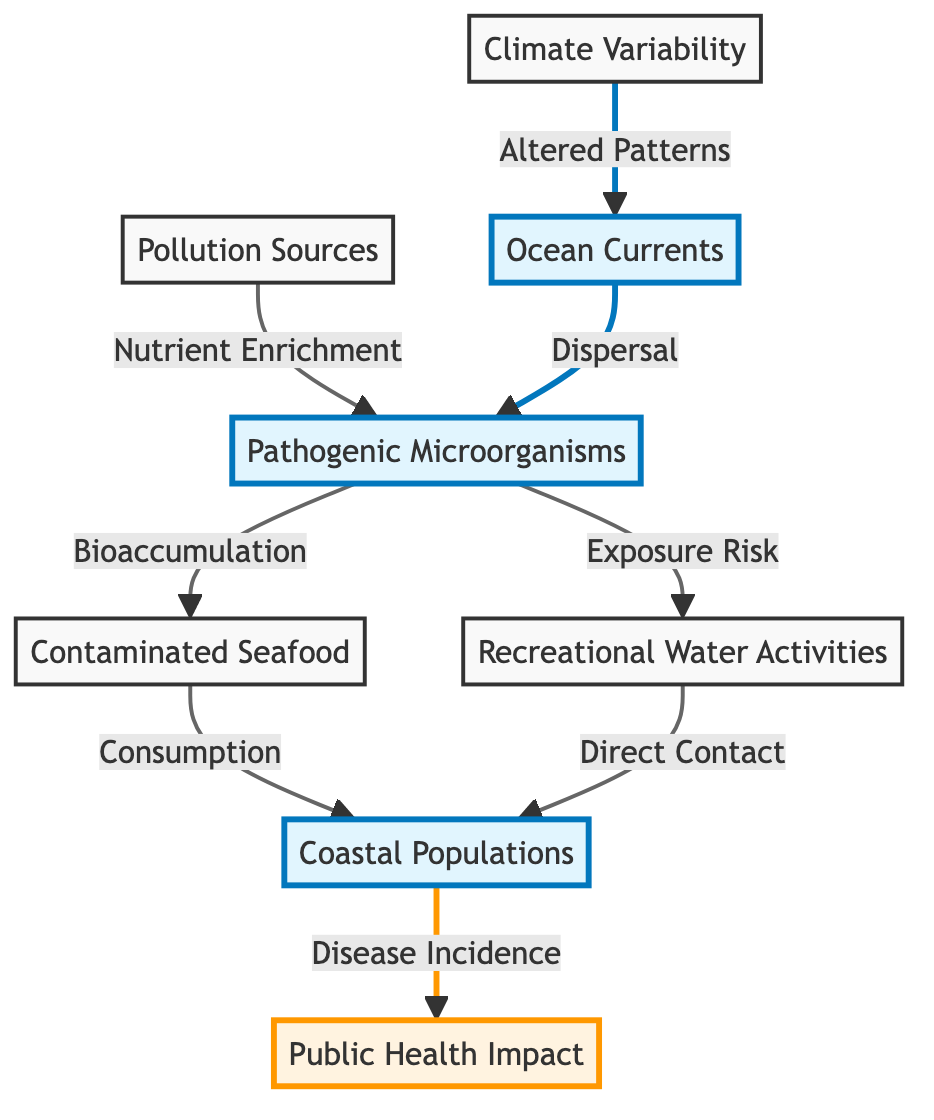What is the central node of the diagram? The central node in the diagram is "Ocean Currents," which serves as a key element influencing the transmission routes of pathogenic microorganisms.
Answer: Ocean Currents How many primary nodes are present in the diagram? The diagram includes a total of 8 primary nodes that represent the key components related to the transmission of pathogenic microorganisms.
Answer: 8 What relationship is depicted between pollution sources and pathogenic microorganisms? The relationship shown indicates that pollution sources contribute to nutrient enrichment, which facilitates the growth and transmission of pathogenic microorganisms.
Answer: Nutrient Enrichment What effect does climate variability have on ocean currents? Climate variability leads to altered patterns in ocean currents, which are crucial for the dispersal of pathogenic microorganisms.
Answer: Altered Patterns Which nodes are directly connected to coastal populations? The nodes that are directly connected to coastal populations include "Contaminated Seafood" and "Recreational Water Activities," both representing exposure routes.
Answer: Contaminated Seafood, Recreational Water Activities Explain the progression from pathogenic microorganisms to public health impact. Pathogenic microorganisms can lead to bioaccumulation in contaminated seafood and increase exposure risk through recreational activities. Both paths converge in coastal populations, ultimately influencing disease incidence and impacting public health.
Answer: Disease Incidence What type of risk is highlighted from recreational water activities? The diagram indicates that recreational water activities are associated with a direct contact exposure risk to pathogenic microorganisms.
Answer: Direct Contact What is the consequence of consuming contaminated seafood? Consuming contaminated seafood connects directly to the occurrence of disease incidence in coastal populations, indicating a health risk associated with this route of exposure.
Answer: Disease Incidence 